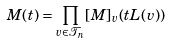<formula> <loc_0><loc_0><loc_500><loc_500>M ( t ) = \prod _ { v \in \mathcal { T } _ { n } } [ M ] _ { v } ( t L ( v ) )</formula> 